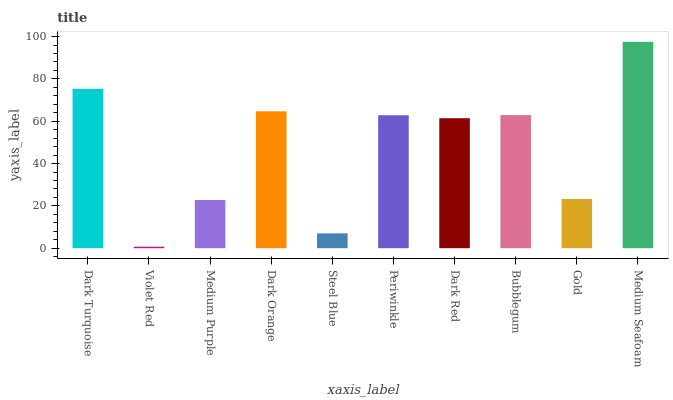Is Violet Red the minimum?
Answer yes or no. Yes. Is Medium Seafoam the maximum?
Answer yes or no. Yes. Is Medium Purple the minimum?
Answer yes or no. No. Is Medium Purple the maximum?
Answer yes or no. No. Is Medium Purple greater than Violet Red?
Answer yes or no. Yes. Is Violet Red less than Medium Purple?
Answer yes or no. Yes. Is Violet Red greater than Medium Purple?
Answer yes or no. No. Is Medium Purple less than Violet Red?
Answer yes or no. No. Is Periwinkle the high median?
Answer yes or no. Yes. Is Dark Red the low median?
Answer yes or no. Yes. Is Gold the high median?
Answer yes or no. No. Is Periwinkle the low median?
Answer yes or no. No. 